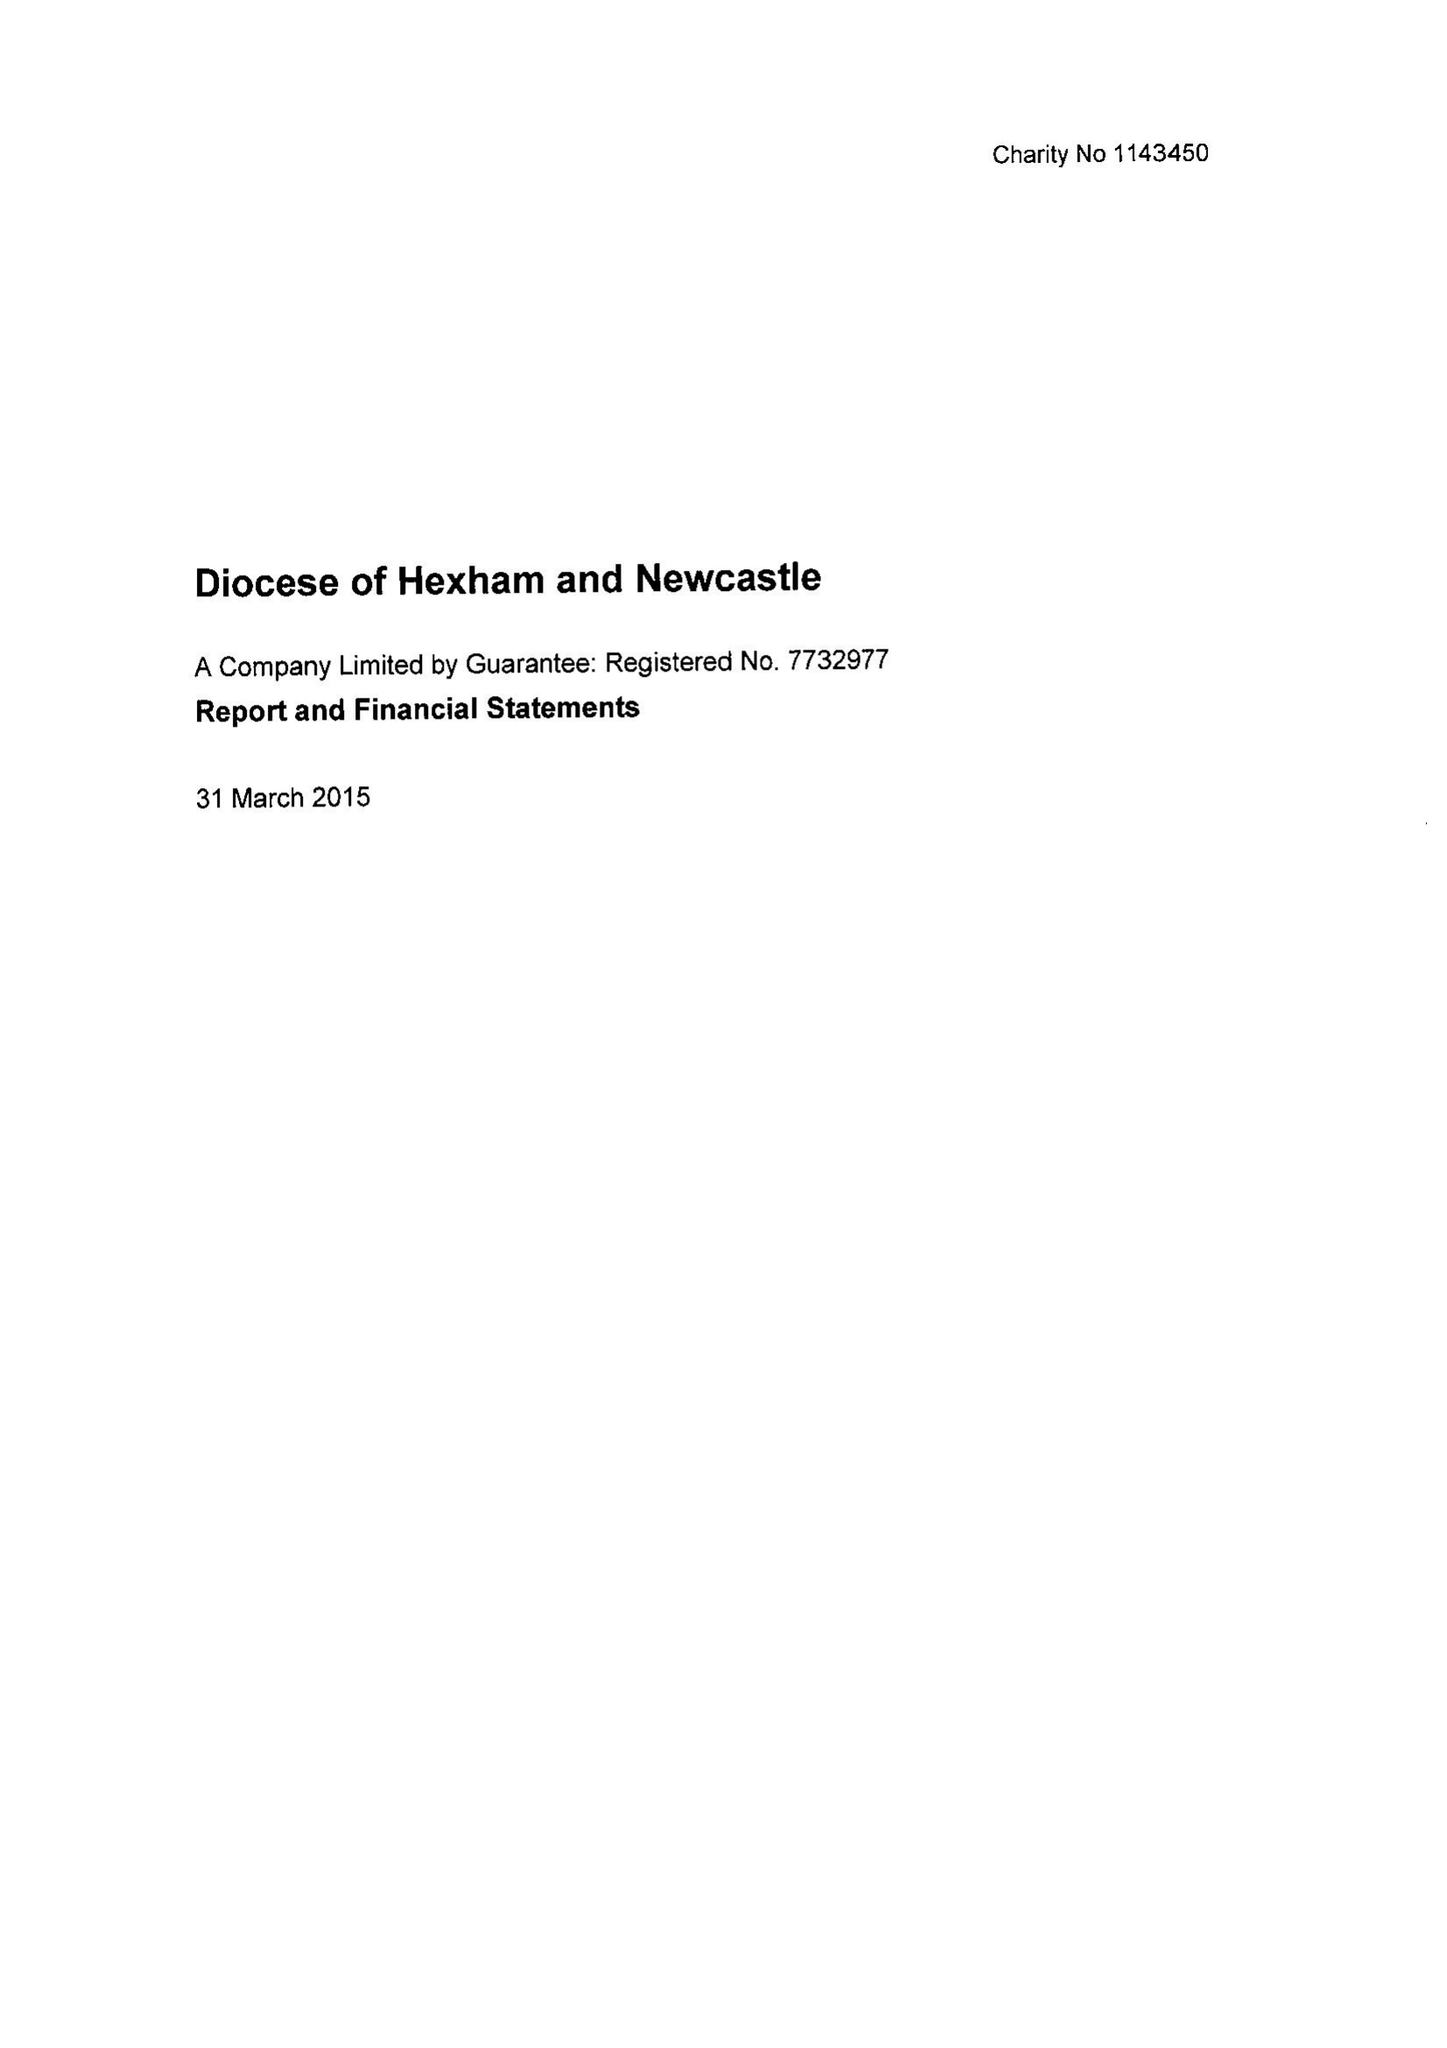What is the value for the address__street_line?
Answer the question using a single word or phrase. WEST ROAD 